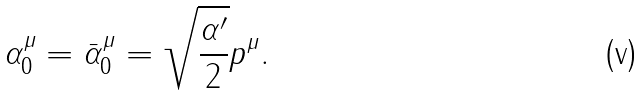Convert formula to latex. <formula><loc_0><loc_0><loc_500><loc_500>\alpha _ { 0 } ^ { \mu } = \bar { \alpha } _ { 0 } ^ { \mu } = \sqrt { \frac { \alpha ^ { \prime } } 2 } p ^ { \mu } .</formula> 